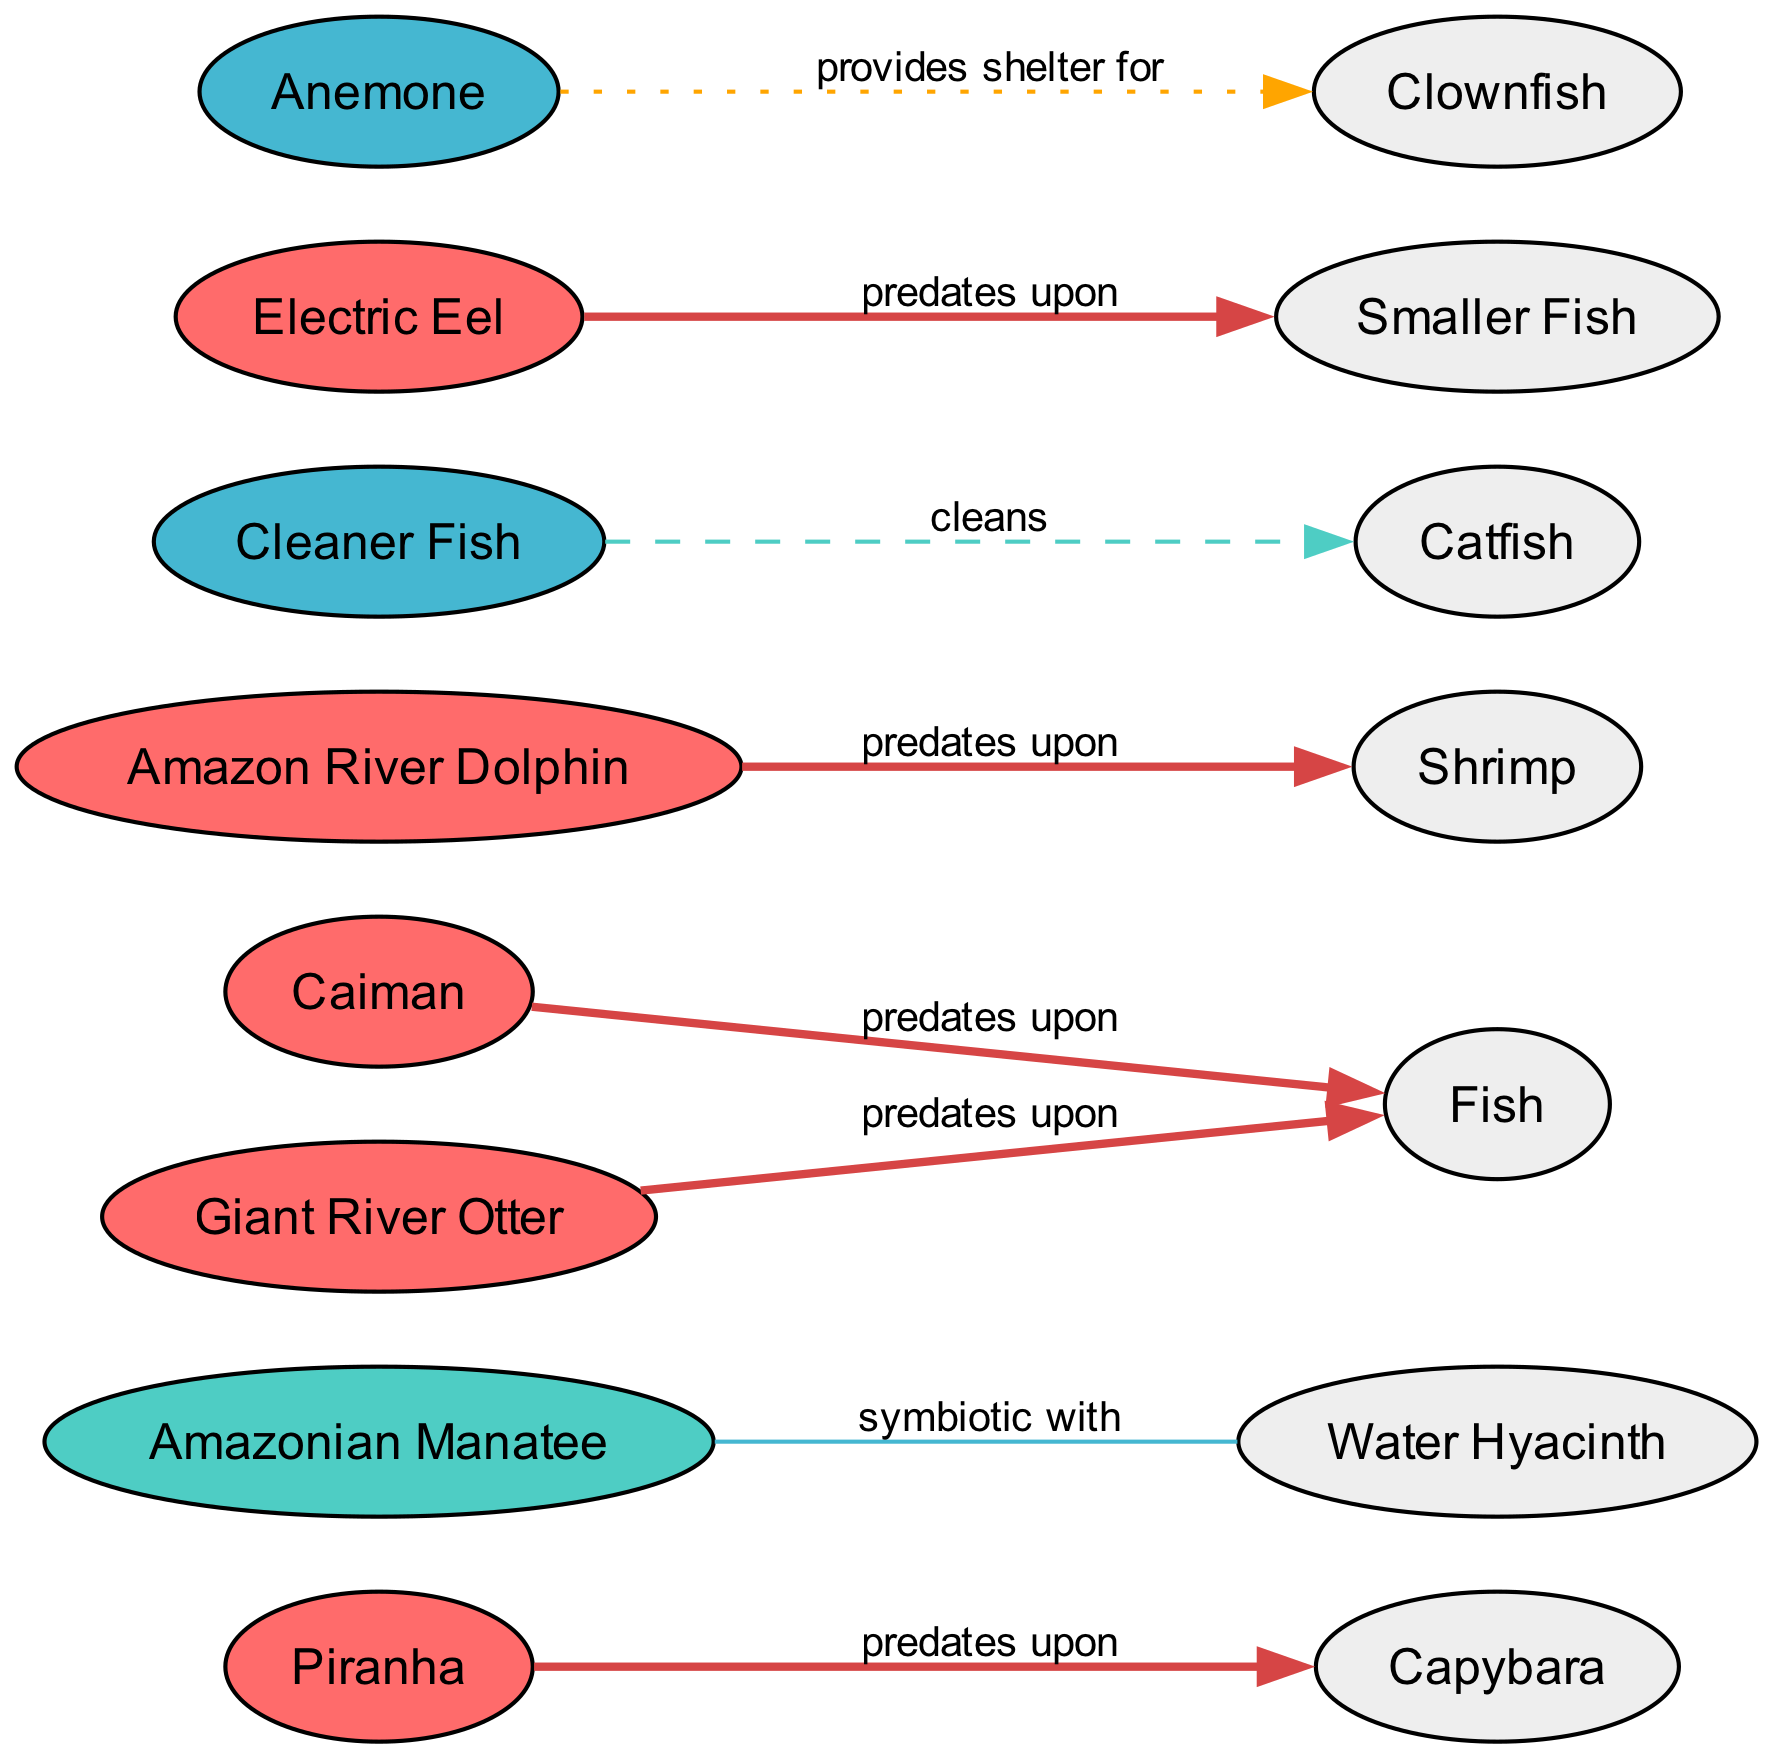What aquatic species does the Piranha predate upon? The directed edge from Piranha leads to Capybara, stating the relationship that Piranha predates upon Capybara.
Answer: Capybara How many predator species are represented in the diagram? Counting the nodes marked as predators in the diagram: Piranha, Caiman, Amazon River Dolphin, Electric Eel, and Giant River Otter, we find there are five predator species.
Answer: 5 What is the relationship type between the Amazonian Manatee and Water Hyacinth? The edge connecting Amazonian Manatee to Water Hyacinth indicates a symbiotic relationship, specifically that they are symbiotic with each other.
Answer: Symbiotic with Which species provides shelter for the Clownfish? The Anemone node has a directed edge to Clownfish, denoting that Anemone provides shelter for Clownfish.
Answer: Anemone Which two species are involved in a cleaning relationship? The edge from Cleaner Fish to Catfish indicates a cleaning relationship, showing that Cleaner Fish cleans Catfish.
Answer: Cleaner Fish and Catfish What color represents symbiont nodes in the diagram? The color scheme for symbiont nodes is specifically indicated as #45B7D1. This can be deduced from how the nodes are colored in the visual representation.
Answer: #45B7D1 Which species is the only herbivore shown in the diagram? The Amazonian Manatee is distinctly marked as the only herbivore in the diagram, noted in its type classification.
Answer: Amazonian Manatee What type of relationship is represented by the edge leading from Cleaner Fish to Catfish? The relationship is indicated as dashed in the diagram, which signifies a cleaning relationship.
Answer: Cleans How many total edges are present in the diagram? By counting all the directed connections (edges), we establish there are eight total edges in the diagram, making note of both predation and symbiotic relationships.
Answer: 8 